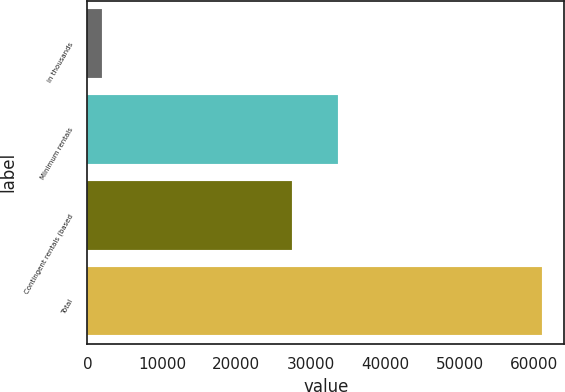<chart> <loc_0><loc_0><loc_500><loc_500><bar_chart><fcel>in thousands<fcel>Minimum rentals<fcel>Contingent rentals (based<fcel>Total<nl><fcel>2010<fcel>33573<fcel>27418<fcel>60991<nl></chart> 